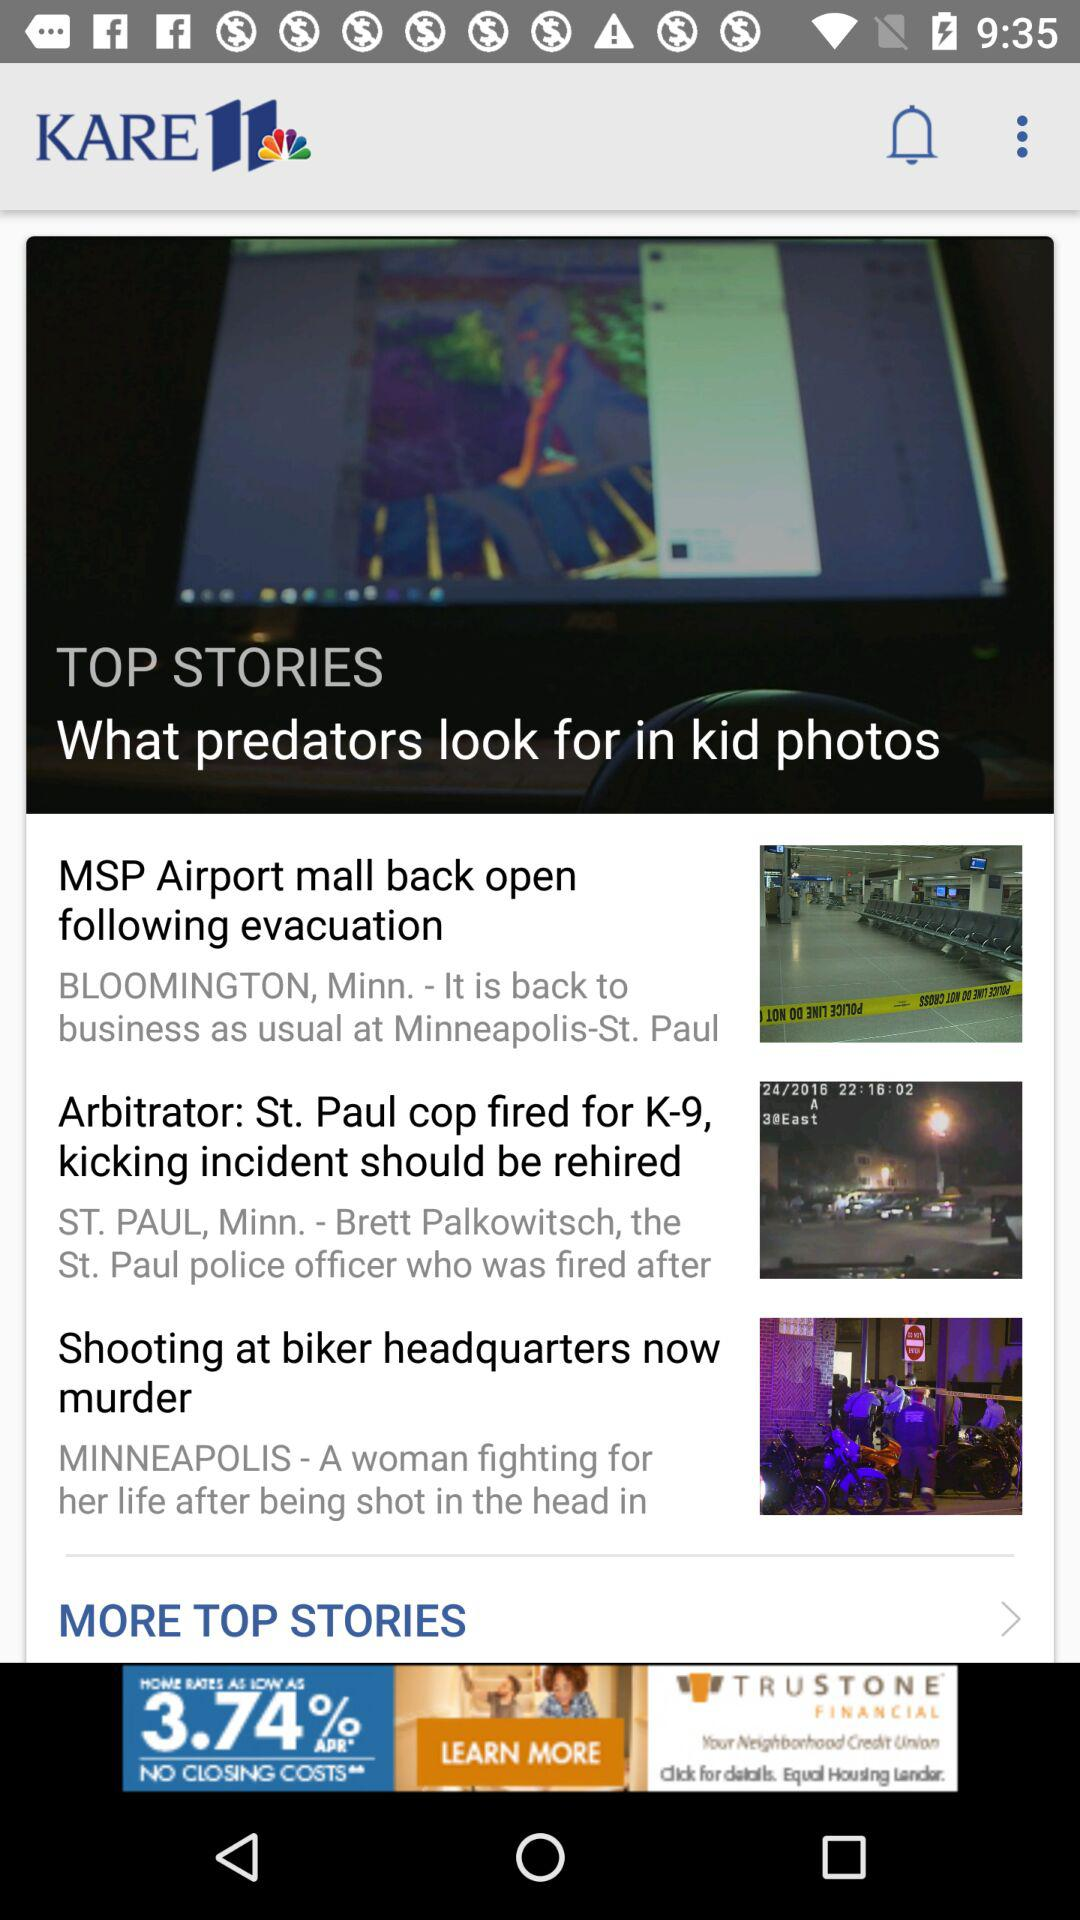How many more stories are there after the first story?
Answer the question using a single word or phrase. 2 